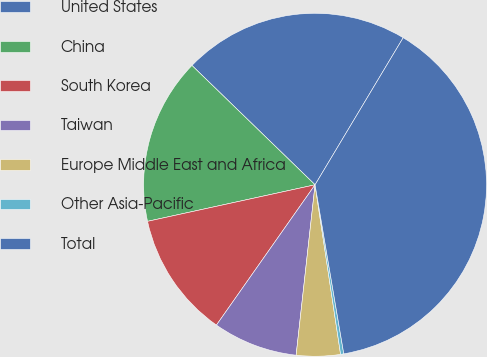Convert chart to OTSL. <chart><loc_0><loc_0><loc_500><loc_500><pie_chart><fcel>United States<fcel>China<fcel>South Korea<fcel>Taiwan<fcel>Europe Middle East and Africa<fcel>Other Asia-Pacific<fcel>Total<nl><fcel>21.34%<fcel>15.67%<fcel>11.83%<fcel>7.99%<fcel>4.14%<fcel>0.3%<fcel>38.73%<nl></chart> 